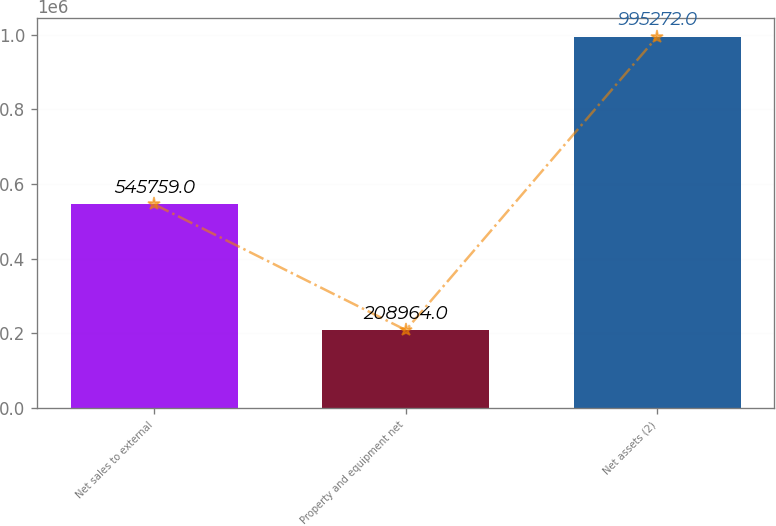Convert chart to OTSL. <chart><loc_0><loc_0><loc_500><loc_500><bar_chart><fcel>Net sales to external<fcel>Property and equipment net<fcel>Net assets (2)<nl><fcel>545759<fcel>208964<fcel>995272<nl></chart> 